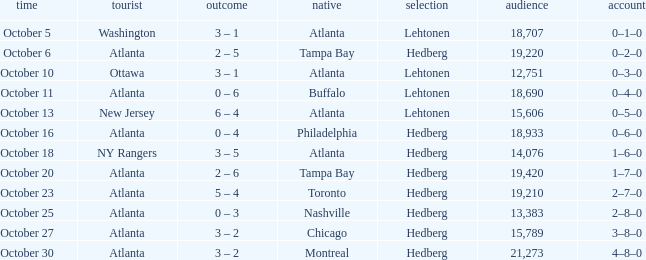What was the record on the game that was played on october 27? 3–8–0. 